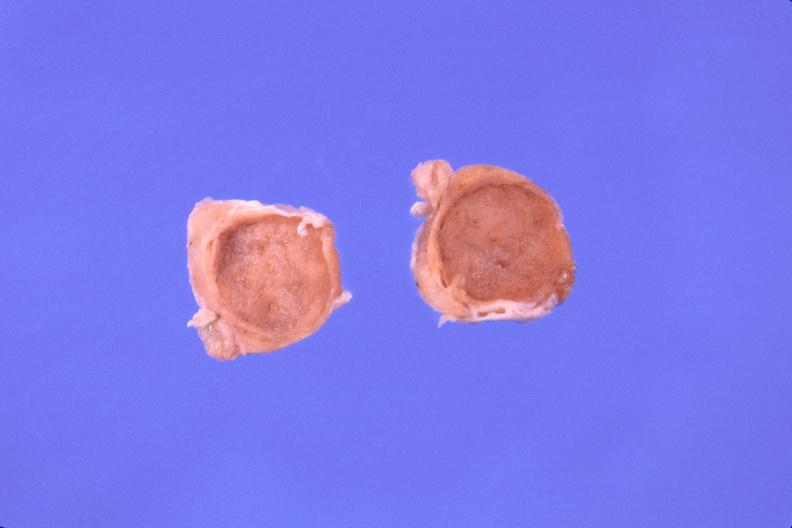what is present?
Answer the question using a single word or phrase. Endocrine 